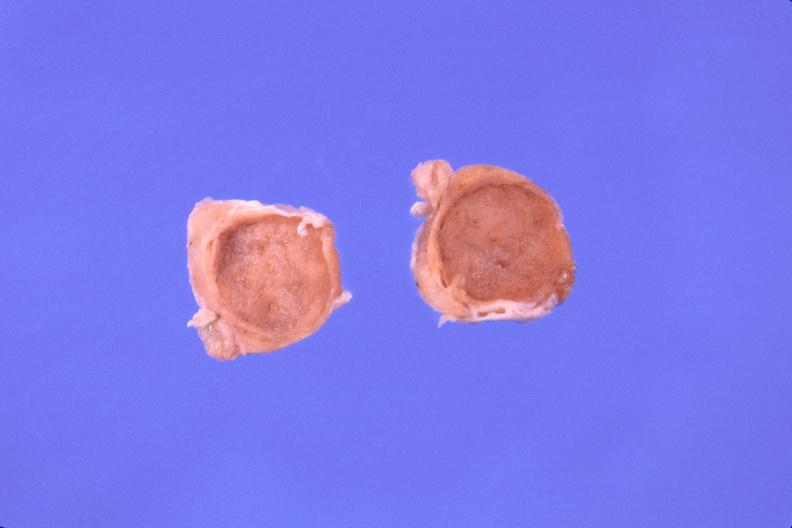what is present?
Answer the question using a single word or phrase. Endocrine 